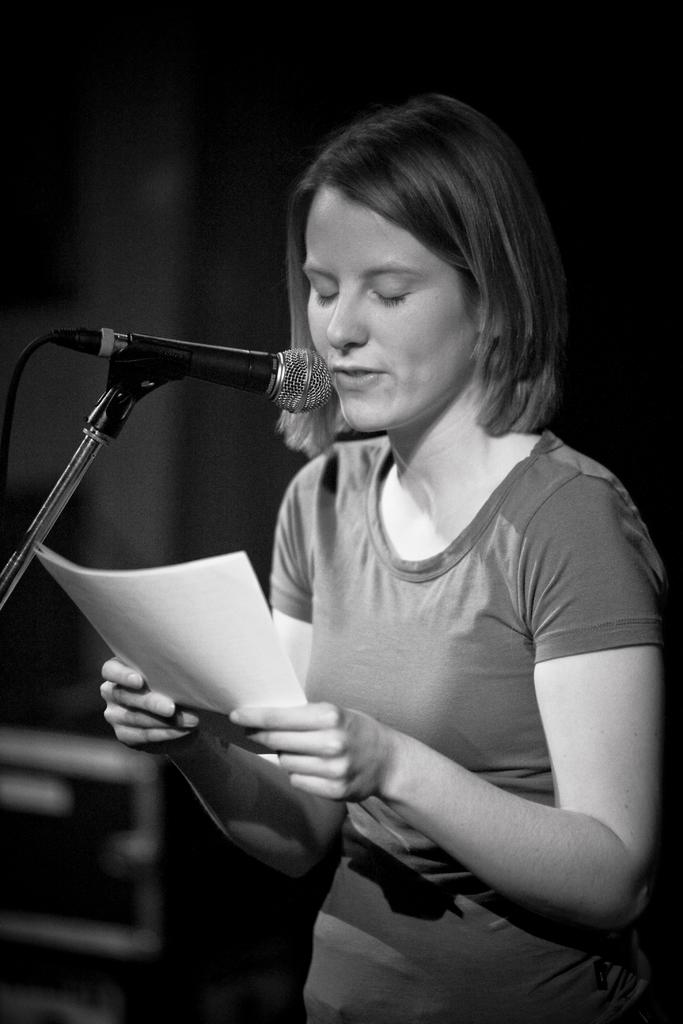Who is the main subject in the image? There is a woman in the center of the image. What is the woman doing in the image? The woman is standing and speaking. What is the woman holding in the image? The woman is holding a paper. What object is in front of the woman? There is a microphone in front of the woman. How would you describe the background of the image? The background of the image is blurry. Can you tell me how many frogs are visible in the image? There are no frogs visible in the image. What month is the woman speaking in the image? The month is not mentioned or visible in the image. 